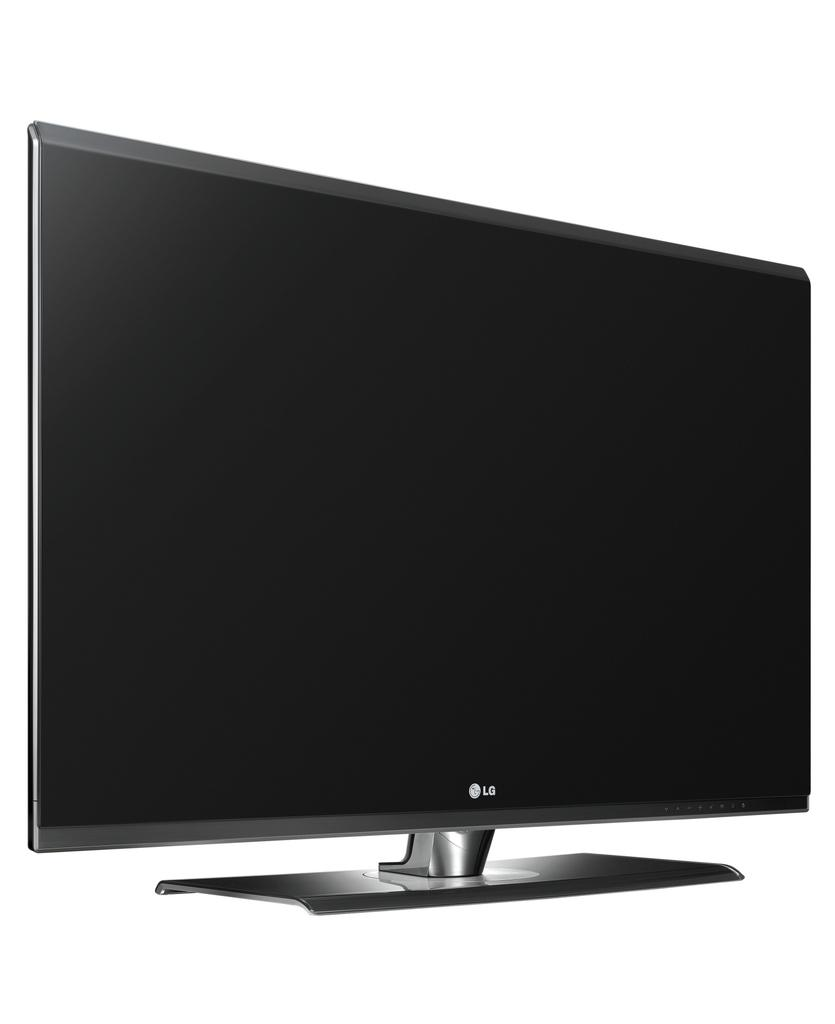Provide a one-sentence caption for the provided image. A white screen with a LG computer monitor that is turned off. 